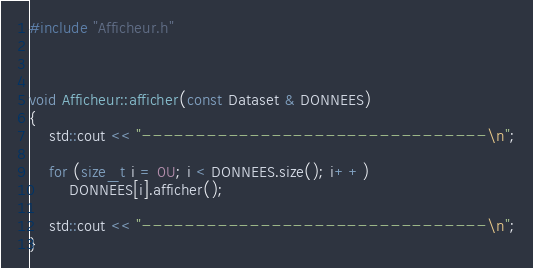<code> <loc_0><loc_0><loc_500><loc_500><_C++_>#include "Afficheur.h"



void Afficheur::afficher(const Dataset & DONNEES)
{
	std::cout << "--------------------------------\n";

	for (size_t i = 0U; i < DONNEES.size(); i++)
		DONNEES[i].afficher();

	std::cout << "--------------------------------\n";
}
</code> 